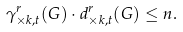Convert formula to latex. <formula><loc_0><loc_0><loc_500><loc_500>\gamma _ { \times k , t } ^ { r } ( G ) \cdot d _ { \times k , t } ^ { r } ( G ) \leq n .</formula> 